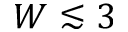Convert formula to latex. <formula><loc_0><loc_0><loc_500><loc_500>W \lesssim 3</formula> 